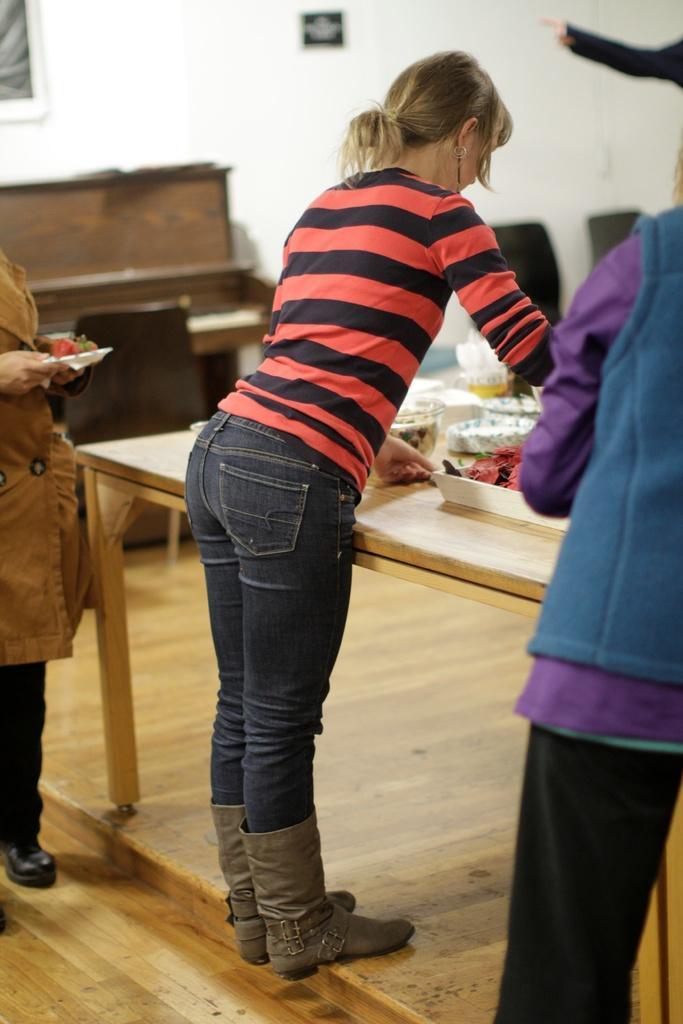Describe this image in one or two sentences. In this image, there is a table which is in yellow color, on that table there are food items kept, in the middle there is a girl she is standing and she is holding a object, there are some people standing, there is a black color chair, in the background there is a white color wall. 